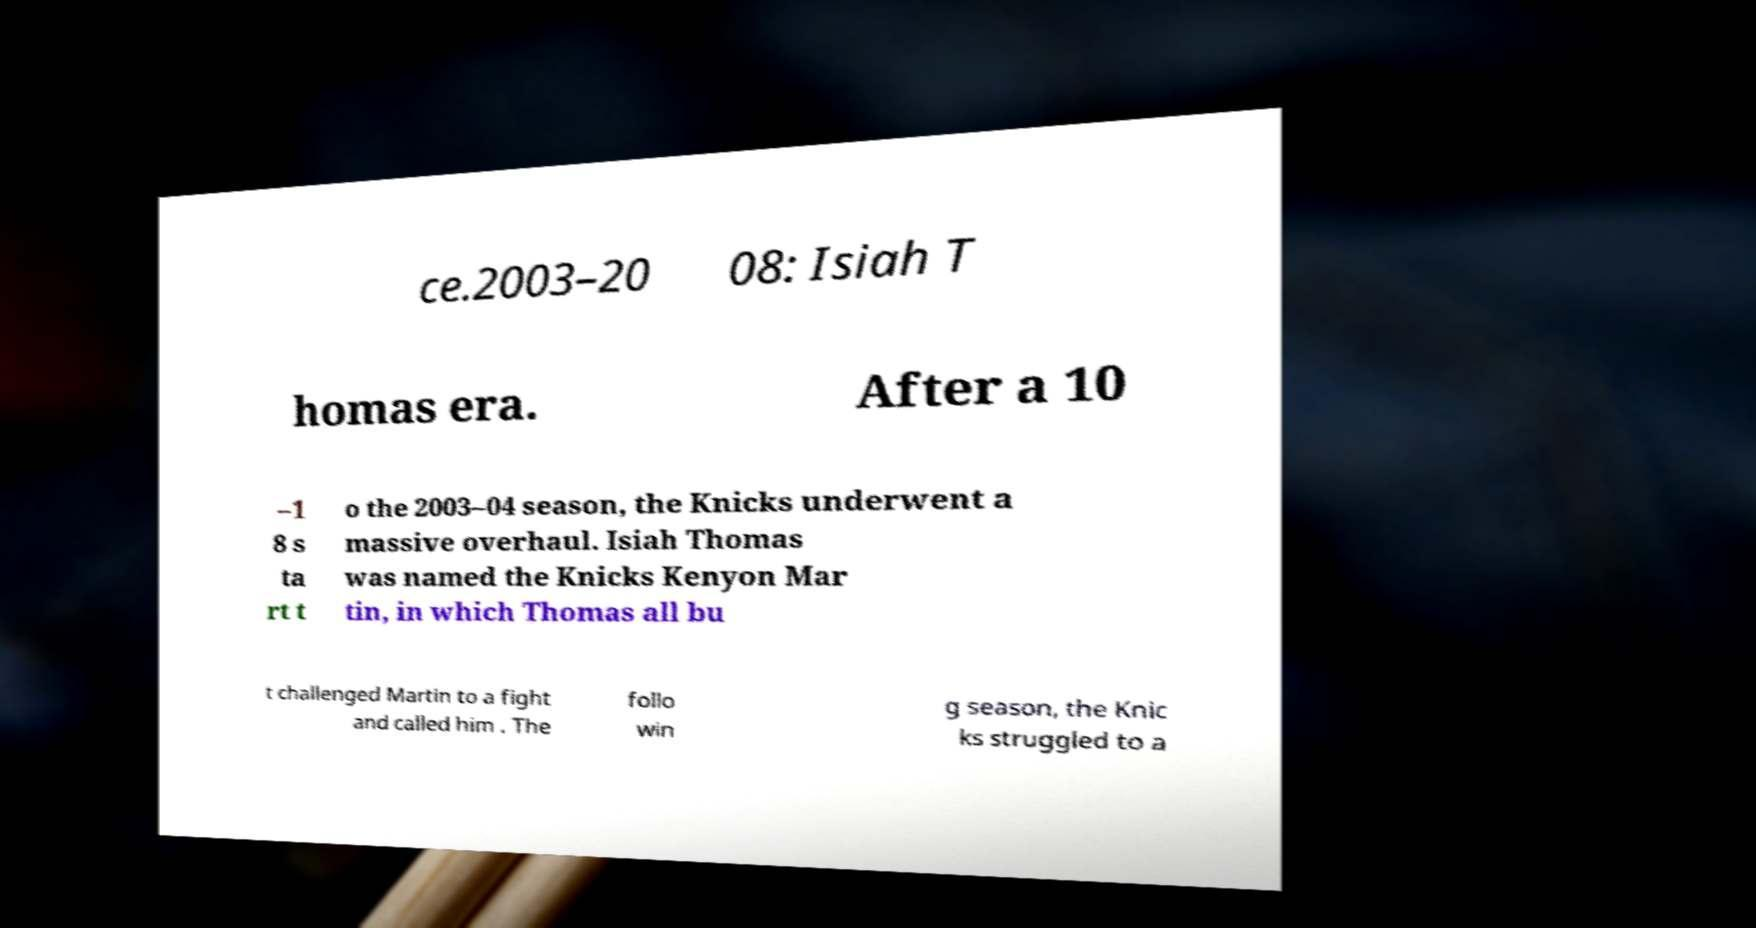Could you assist in decoding the text presented in this image and type it out clearly? ce.2003–20 08: Isiah T homas era. After a 10 –1 8 s ta rt t o the 2003–04 season, the Knicks underwent a massive overhaul. Isiah Thomas was named the Knicks Kenyon Mar tin, in which Thomas all bu t challenged Martin to a fight and called him . The follo win g season, the Knic ks struggled to a 